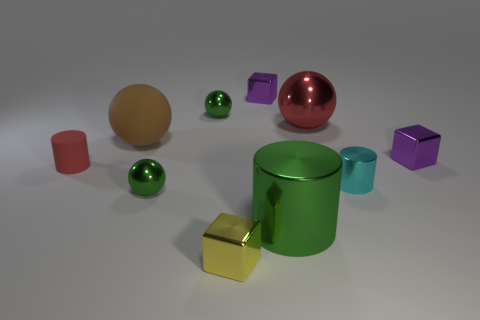Is the shape of the green metallic thing that is on the right side of the tiny yellow object the same as  the red matte object?
Your answer should be compact. Yes. Are there fewer small green metallic objects than brown rubber things?
Your answer should be compact. No. There is a yellow cube that is the same size as the red rubber cylinder; what is its material?
Provide a short and direct response. Metal. There is a rubber cylinder; is it the same color as the tiny block to the right of the big red object?
Offer a very short reply. No. Are there fewer tiny rubber cylinders that are right of the small metallic cylinder than gray balls?
Ensure brevity in your answer.  No. How many small objects are there?
Keep it short and to the point. 7. The tiny yellow metal object right of the green ball in front of the red cylinder is what shape?
Ensure brevity in your answer.  Cube. There is a cyan cylinder; what number of tiny shiny objects are right of it?
Your answer should be very brief. 1. Do the cyan cylinder and the big object in front of the red cylinder have the same material?
Give a very brief answer. Yes. Is there a yellow object of the same size as the red cylinder?
Ensure brevity in your answer.  Yes. 